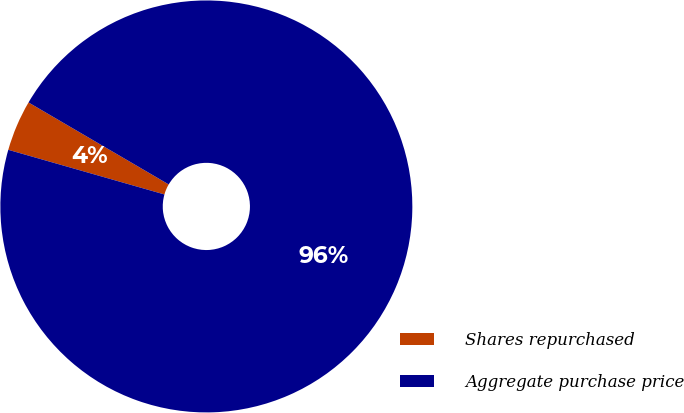Convert chart to OTSL. <chart><loc_0><loc_0><loc_500><loc_500><pie_chart><fcel>Shares repurchased<fcel>Aggregate purchase price<nl><fcel>3.99%<fcel>96.01%<nl></chart> 